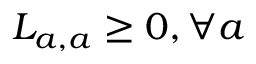Convert formula to latex. <formula><loc_0><loc_0><loc_500><loc_500>L _ { a , a } \geq 0 , \forall a</formula> 